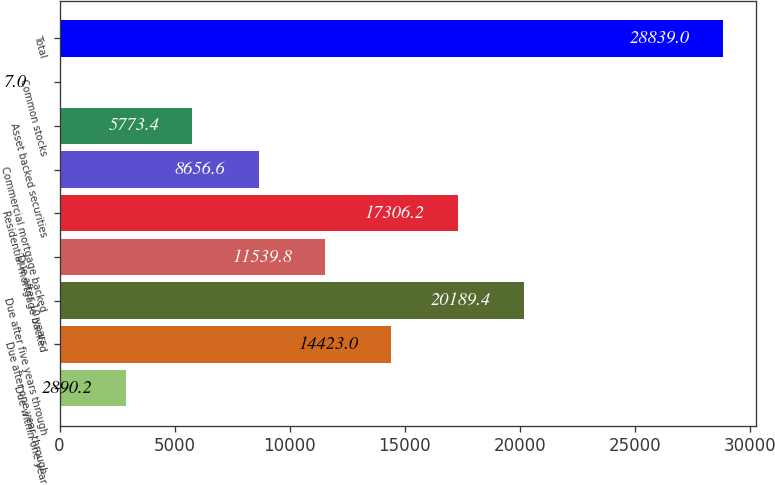Convert chart to OTSL. <chart><loc_0><loc_0><loc_500><loc_500><bar_chart><fcel>Due within one year<fcel>Due after one year through<fcel>Due after five years through<fcel>Due after 10 years<fcel>Residential mortgage backed<fcel>Commercial mortgage backed<fcel>Asset backed securities<fcel>Common stocks<fcel>Total<nl><fcel>2890.2<fcel>14423<fcel>20189.4<fcel>11539.8<fcel>17306.2<fcel>8656.6<fcel>5773.4<fcel>7<fcel>28839<nl></chart> 